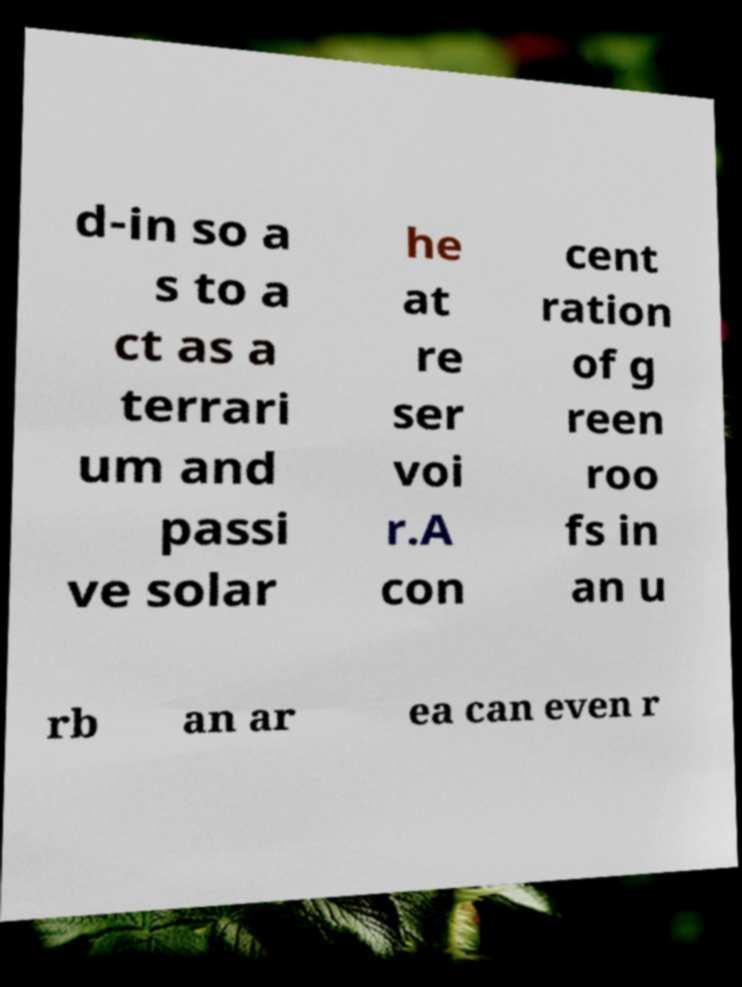Can you read and provide the text displayed in the image?This photo seems to have some interesting text. Can you extract and type it out for me? d-in so a s to a ct as a terrari um and passi ve solar he at re ser voi r.A con cent ration of g reen roo fs in an u rb an ar ea can even r 